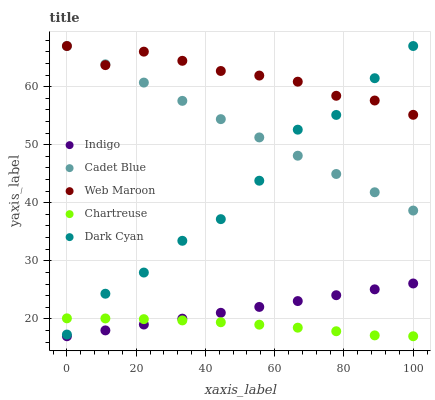Does Chartreuse have the minimum area under the curve?
Answer yes or no. Yes. Does Web Maroon have the maximum area under the curve?
Answer yes or no. Yes. Does Web Maroon have the minimum area under the curve?
Answer yes or no. No. Does Chartreuse have the maximum area under the curve?
Answer yes or no. No. Is Indigo the smoothest?
Answer yes or no. Yes. Is Dark Cyan the roughest?
Answer yes or no. Yes. Is Web Maroon the smoothest?
Answer yes or no. No. Is Web Maroon the roughest?
Answer yes or no. No. Does Chartreuse have the lowest value?
Answer yes or no. Yes. Does Web Maroon have the lowest value?
Answer yes or no. No. Does Cadet Blue have the highest value?
Answer yes or no. Yes. Does Chartreuse have the highest value?
Answer yes or no. No. Is Indigo less than Web Maroon?
Answer yes or no. Yes. Is Cadet Blue greater than Indigo?
Answer yes or no. Yes. Does Dark Cyan intersect Web Maroon?
Answer yes or no. Yes. Is Dark Cyan less than Web Maroon?
Answer yes or no. No. Is Dark Cyan greater than Web Maroon?
Answer yes or no. No. Does Indigo intersect Web Maroon?
Answer yes or no. No. 